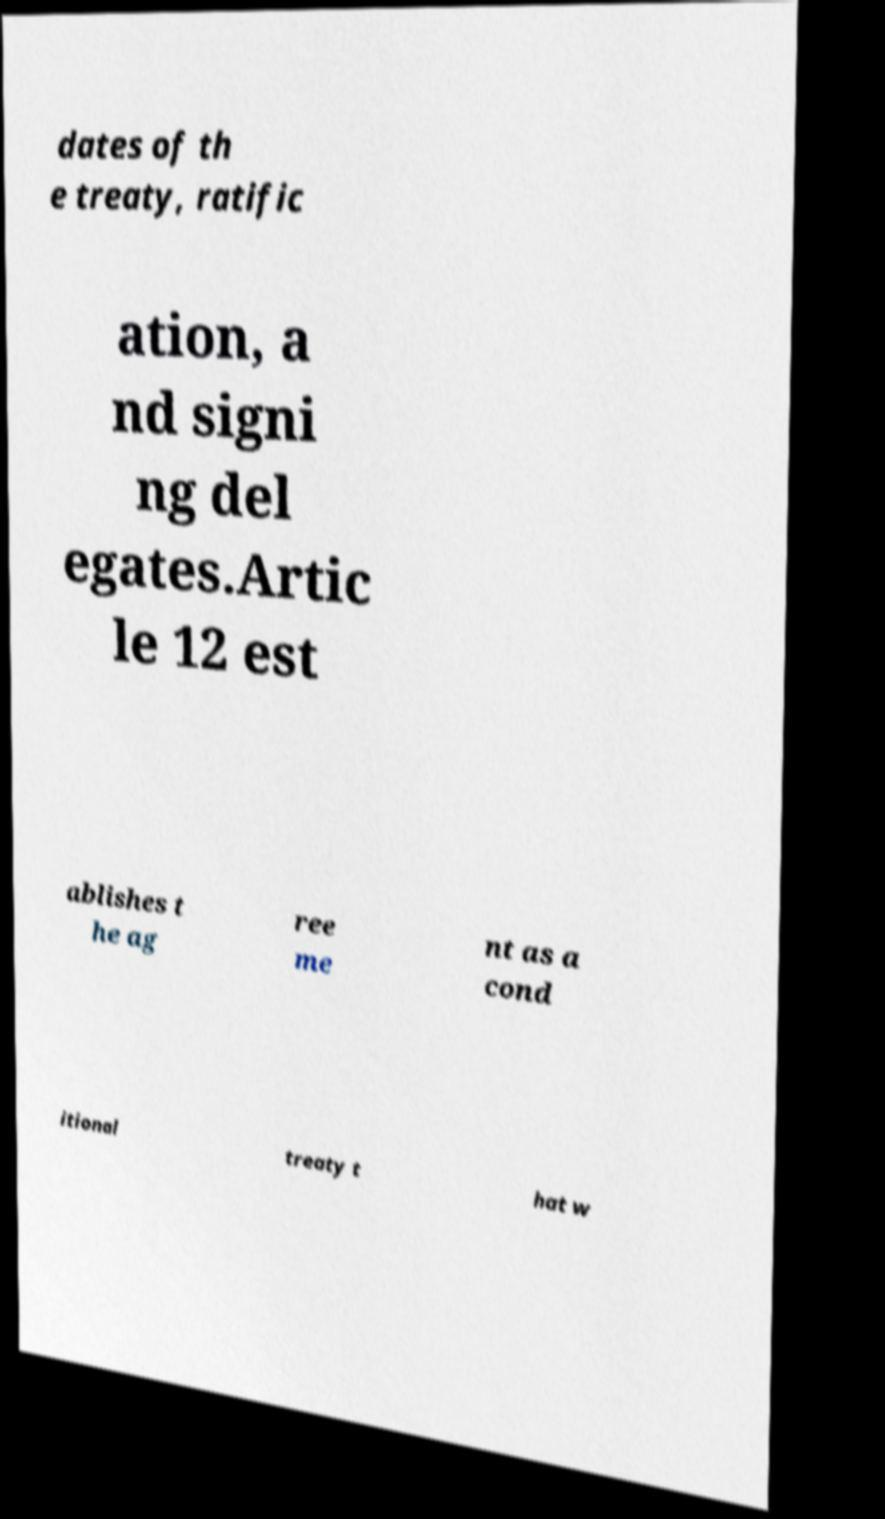For documentation purposes, I need the text within this image transcribed. Could you provide that? dates of th e treaty, ratific ation, a nd signi ng del egates.Artic le 12 est ablishes t he ag ree me nt as a cond itional treaty t hat w 